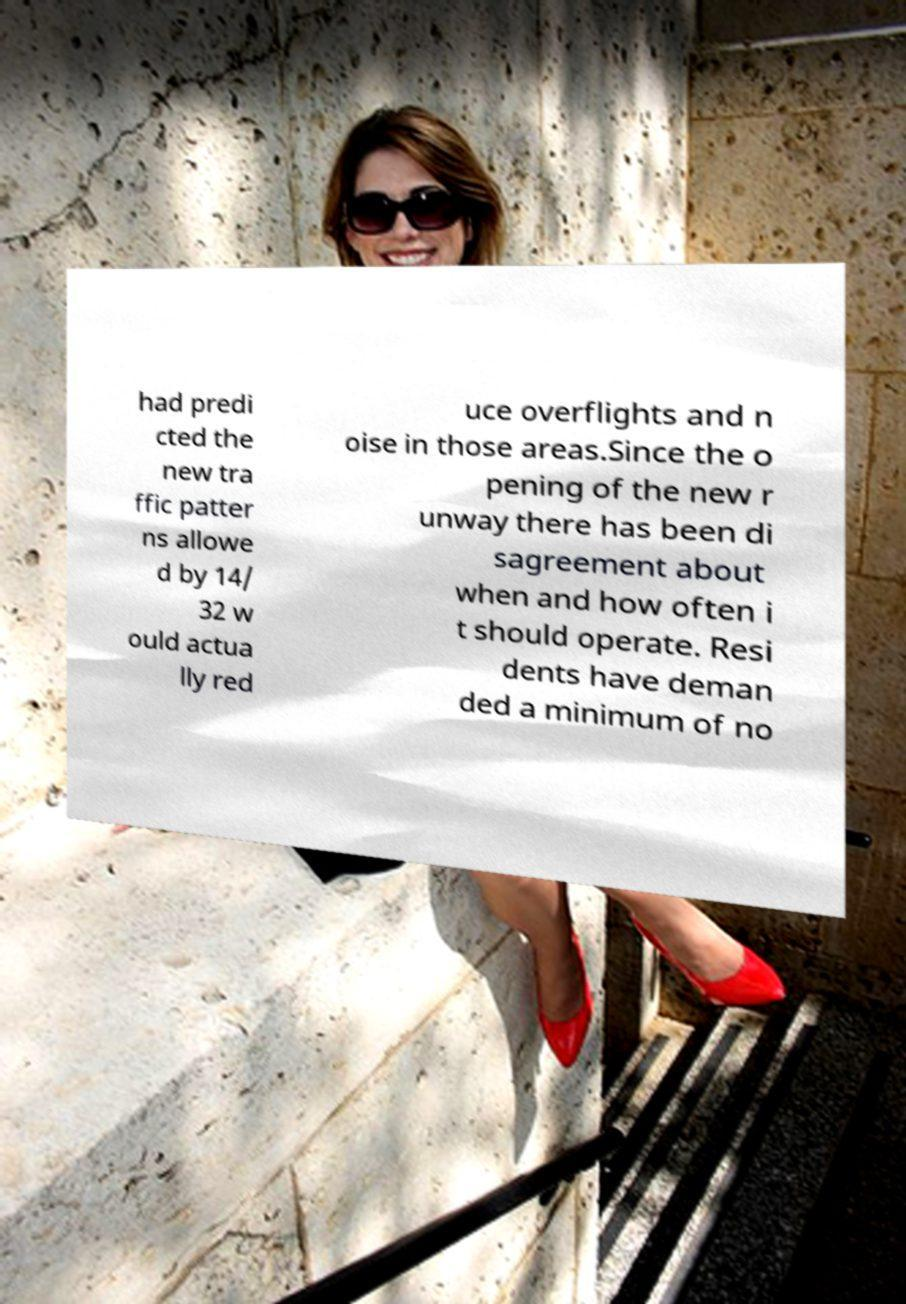What messages or text are displayed in this image? I need them in a readable, typed format. had predi cted the new tra ffic patter ns allowe d by 14/ 32 w ould actua lly red uce overflights and n oise in those areas.Since the o pening of the new r unway there has been di sagreement about when and how often i t should operate. Resi dents have deman ded a minimum of no 